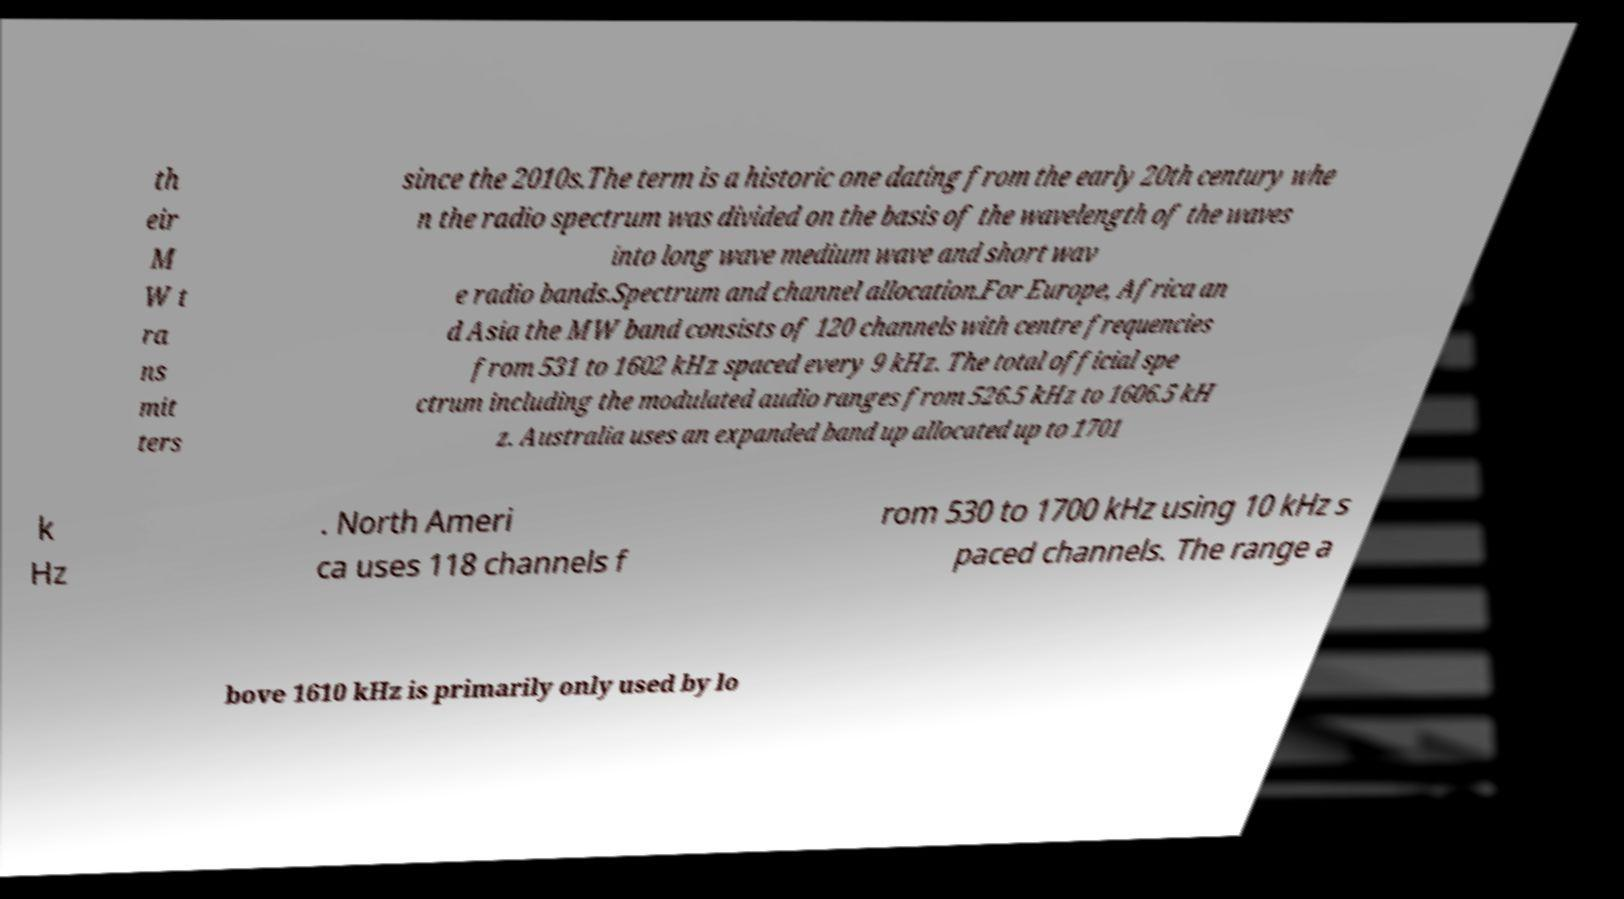Can you accurately transcribe the text from the provided image for me? th eir M W t ra ns mit ters since the 2010s.The term is a historic one dating from the early 20th century whe n the radio spectrum was divided on the basis of the wavelength of the waves into long wave medium wave and short wav e radio bands.Spectrum and channel allocation.For Europe, Africa an d Asia the MW band consists of 120 channels with centre frequencies from 531 to 1602 kHz spaced every 9 kHz. The total official spe ctrum including the modulated audio ranges from 526.5 kHz to 1606.5 kH z. Australia uses an expanded band up allocated up to 1701 k Hz . North Ameri ca uses 118 channels f rom 530 to 1700 kHz using 10 kHz s paced channels. The range a bove 1610 kHz is primarily only used by lo 